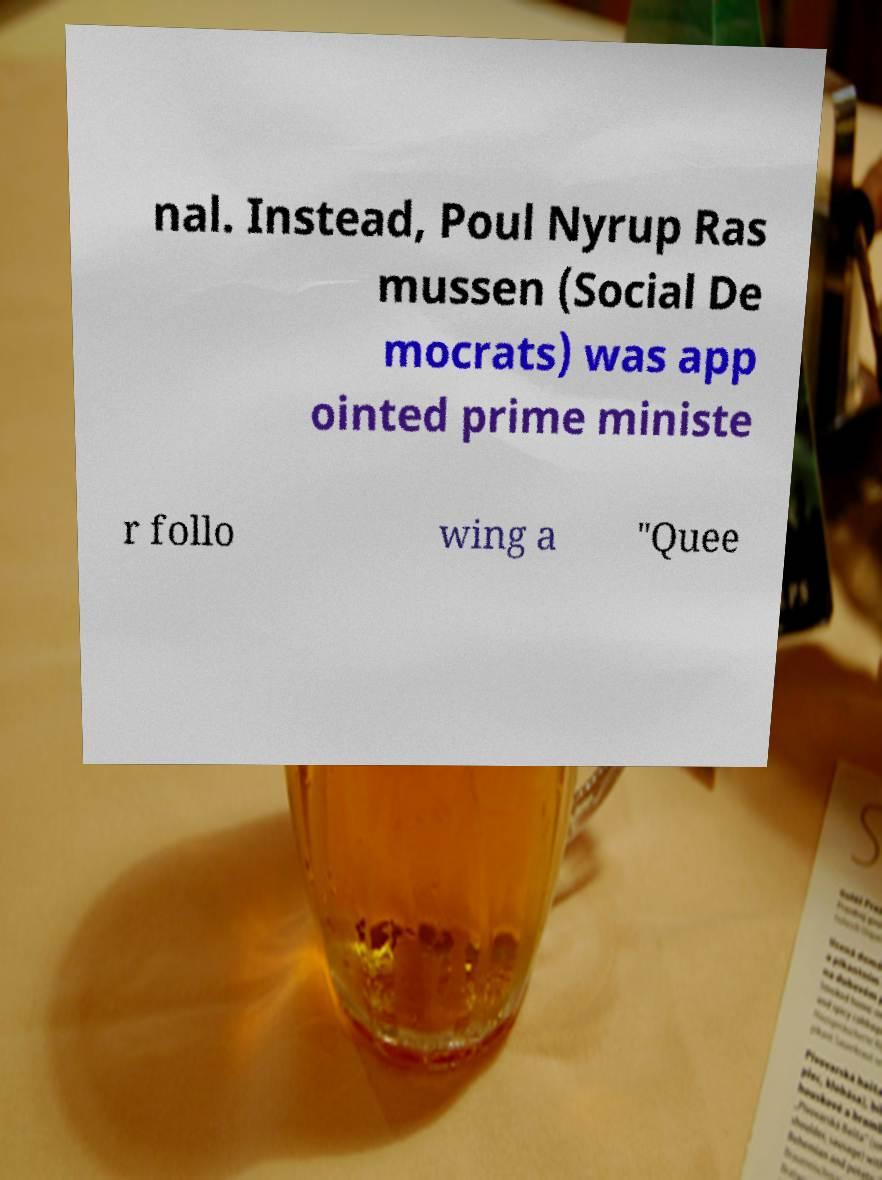Please identify and transcribe the text found in this image. nal. Instead, Poul Nyrup Ras mussen (Social De mocrats) was app ointed prime ministe r follo wing a "Quee 